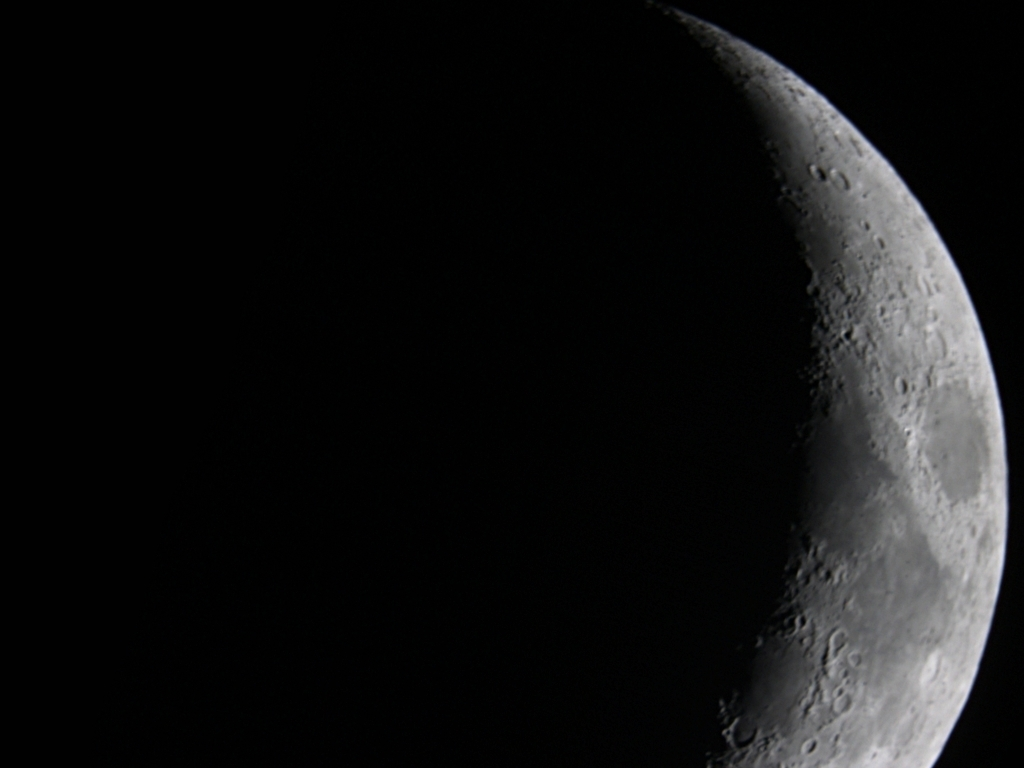What is the texture detail of the photographed planet in this image? The surface texture of the moon in the image is rugged and diverse, with numerous craters and rocky formations visible. The craters vary in size and depth, reflecting a history of meteorite impacts. The shadows cast by the sun highlight the uneven terrain, adding to the detailed texture evident across the lunar surface. 